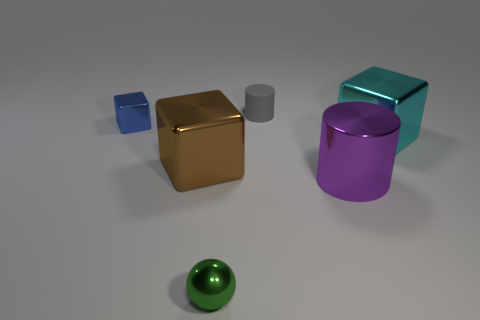Add 3 tiny green shiny balls. How many objects exist? 9 Subtract all cylinders. How many objects are left? 4 Subtract 0 red blocks. How many objects are left? 6 Subtract all big purple metallic cubes. Subtract all blue blocks. How many objects are left? 5 Add 3 big shiny blocks. How many big shiny blocks are left? 5 Add 5 green metal spheres. How many green metal spheres exist? 6 